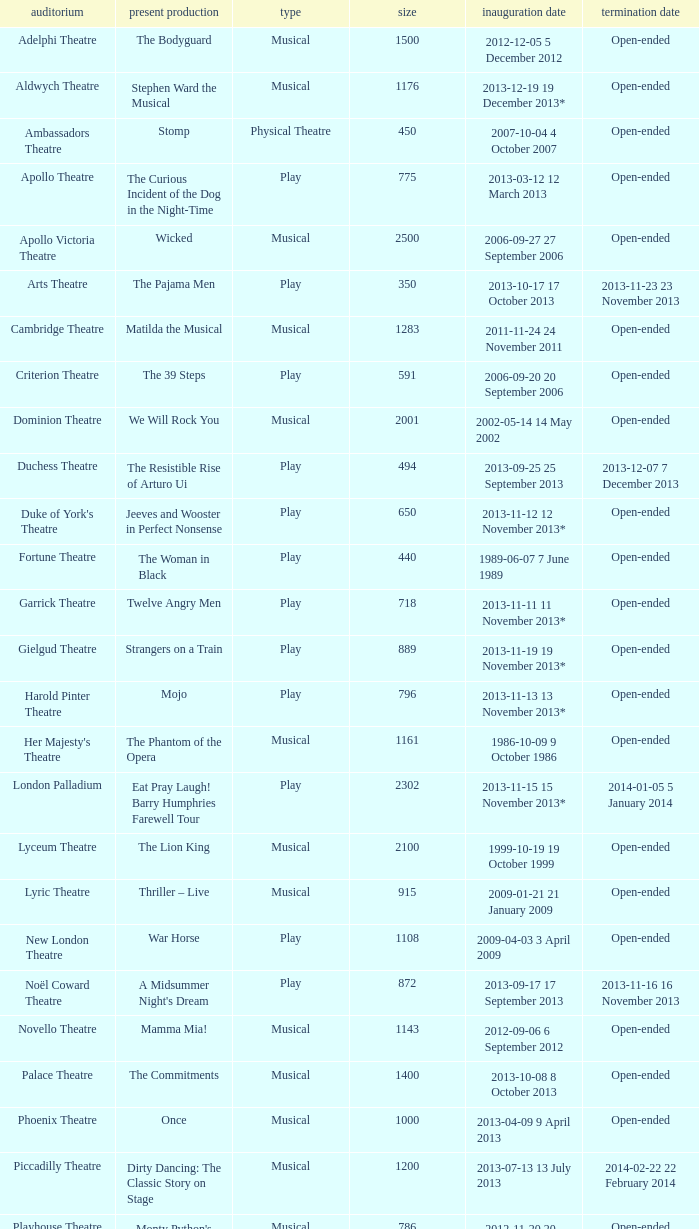Could you parse the entire table as a dict? {'header': ['auditorium', 'present production', 'type', 'size', 'inauguration date', 'termination date'], 'rows': [['Adelphi Theatre', 'The Bodyguard', 'Musical', '1500', '2012-12-05 5 December 2012', 'Open-ended'], ['Aldwych Theatre', 'Stephen Ward the Musical', 'Musical', '1176', '2013-12-19 19 December 2013*', 'Open-ended'], ['Ambassadors Theatre', 'Stomp', 'Physical Theatre', '450', '2007-10-04 4 October 2007', 'Open-ended'], ['Apollo Theatre', 'The Curious Incident of the Dog in the Night-Time', 'Play', '775', '2013-03-12 12 March 2013', 'Open-ended'], ['Apollo Victoria Theatre', 'Wicked', 'Musical', '2500', '2006-09-27 27 September 2006', 'Open-ended'], ['Arts Theatre', 'The Pajama Men', 'Play', '350', '2013-10-17 17 October 2013', '2013-11-23 23 November 2013'], ['Cambridge Theatre', 'Matilda the Musical', 'Musical', '1283', '2011-11-24 24 November 2011', 'Open-ended'], ['Criterion Theatre', 'The 39 Steps', 'Play', '591', '2006-09-20 20 September 2006', 'Open-ended'], ['Dominion Theatre', 'We Will Rock You', 'Musical', '2001', '2002-05-14 14 May 2002', 'Open-ended'], ['Duchess Theatre', 'The Resistible Rise of Arturo Ui', 'Play', '494', '2013-09-25 25 September 2013', '2013-12-07 7 December 2013'], ["Duke of York's Theatre", 'Jeeves and Wooster in Perfect Nonsense', 'Play', '650', '2013-11-12 12 November 2013*', 'Open-ended'], ['Fortune Theatre', 'The Woman in Black', 'Play', '440', '1989-06-07 7 June 1989', 'Open-ended'], ['Garrick Theatre', 'Twelve Angry Men', 'Play', '718', '2013-11-11 11 November 2013*', 'Open-ended'], ['Gielgud Theatre', 'Strangers on a Train', 'Play', '889', '2013-11-19 19 November 2013*', 'Open-ended'], ['Harold Pinter Theatre', 'Mojo', 'Play', '796', '2013-11-13 13 November 2013*', 'Open-ended'], ["Her Majesty's Theatre", 'The Phantom of the Opera', 'Musical', '1161', '1986-10-09 9 October 1986', 'Open-ended'], ['London Palladium', 'Eat Pray Laugh! Barry Humphries Farewell Tour', 'Play', '2302', '2013-11-15 15 November 2013*', '2014-01-05 5 January 2014'], ['Lyceum Theatre', 'The Lion King', 'Musical', '2100', '1999-10-19 19 October 1999', 'Open-ended'], ['Lyric Theatre', 'Thriller – Live', 'Musical', '915', '2009-01-21 21 January 2009', 'Open-ended'], ['New London Theatre', 'War Horse', 'Play', '1108', '2009-04-03 3 April 2009', 'Open-ended'], ['Noël Coward Theatre', "A Midsummer Night's Dream", 'Play', '872', '2013-09-17 17 September 2013', '2013-11-16 16 November 2013'], ['Novello Theatre', 'Mamma Mia!', 'Musical', '1143', '2012-09-06 6 September 2012', 'Open-ended'], ['Palace Theatre', 'The Commitments', 'Musical', '1400', '2013-10-08 8 October 2013', 'Open-ended'], ['Phoenix Theatre', 'Once', 'Musical', '1000', '2013-04-09 9 April 2013', 'Open-ended'], ['Piccadilly Theatre', 'Dirty Dancing: The Classic Story on Stage', 'Musical', '1200', '2013-07-13 13 July 2013', '2014-02-22 22 February 2014'], ['Playhouse Theatre', "Monty Python's Spamalot", 'Musical', '786', '2012-11-20 20 November 2012', 'Open-ended'], ['Prince Edward Theatre', 'Jersey Boys', 'Musical', '1618', '2008-03-18 18 March 2008', '2014-03-09 9 March 2014'], ['Prince of Wales Theatre', 'The Book of Mormon', 'Musical', '1160', '2013-03-21 21 March 2013', 'Open-ended'], ["Queen's Theatre", 'Les Misérables', 'Musical', '1099', '2004-04-12 12 April 2004', 'Open-ended'], ['Savoy Theatre', 'Let It Be', 'Musical', '1158', '2013-02-01 1 February 2013', 'Open-ended'], ['Shaftesbury Theatre', 'From Here to Eternity the Musical', 'Musical', '1400', '2013-10-23 23 October 2013', 'Open-ended'], ['St. James Theatre', 'Scenes from a Marriage', 'Play', '312', '2013-09-11 11 September 2013', '2013-11-9 9 November 2013'], ["St Martin's Theatre", 'The Mousetrap', 'Play', '550', '1974-03-25 25 March 1974', 'Open-ended'], ['Theatre Royal, Haymarket', 'One Man, Two Guvnors', 'Play', '888', '2012-03-02 2 March 2012', '2013-03-01 1 March 2014'], ['Theatre Royal, Drury Lane', 'Charlie and the Chocolate Factory the Musical', 'Musical', '2220', '2013-06-25 25 June 2013', 'Open-ended'], ['Trafalgar Studios 1', 'The Pride', 'Play', '380', '2013-08-13 13 August 2013', '2013-11-23 23 November 2013'], ['Trafalgar Studios 2', 'Mrs. Lowry and Son', 'Play', '100', '2013-11-01 1 November 2013', '2013-11-23 23 November 2013'], ['Vaudeville Theatre', 'The Ladykillers', 'Play', '681', '2013-07-09 9 July 2013', '2013-11-16 16 November 2013'], ['Victoria Palace Theatre', 'Billy Elliot the Musical', 'Musical', '1517', '2005-05-11 11 May 2005', 'Open-ended'], ["Wyndham's Theatre", 'Barking in Essex', 'Play', '750', '2013-09-16 16 September 2013', '2014-01-04 4 January 2014']]} What is the opening date of the musical at the adelphi theatre? 2012-12-05 5 December 2012. 